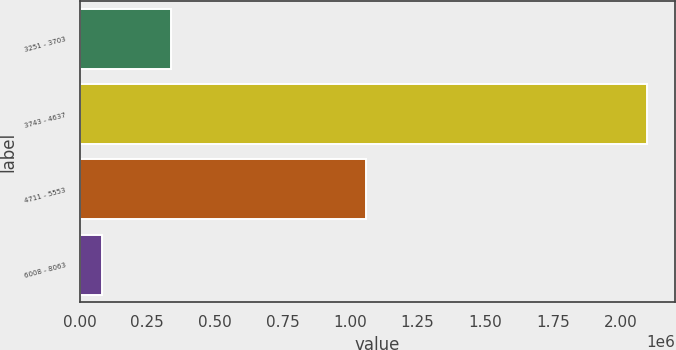<chart> <loc_0><loc_0><loc_500><loc_500><bar_chart><fcel>3251 - 3703<fcel>3743 - 4637<fcel>4711 - 5553<fcel>6008 - 8063<nl><fcel>337875<fcel>2.09655e+06<fcel>1.05963e+06<fcel>83450<nl></chart> 